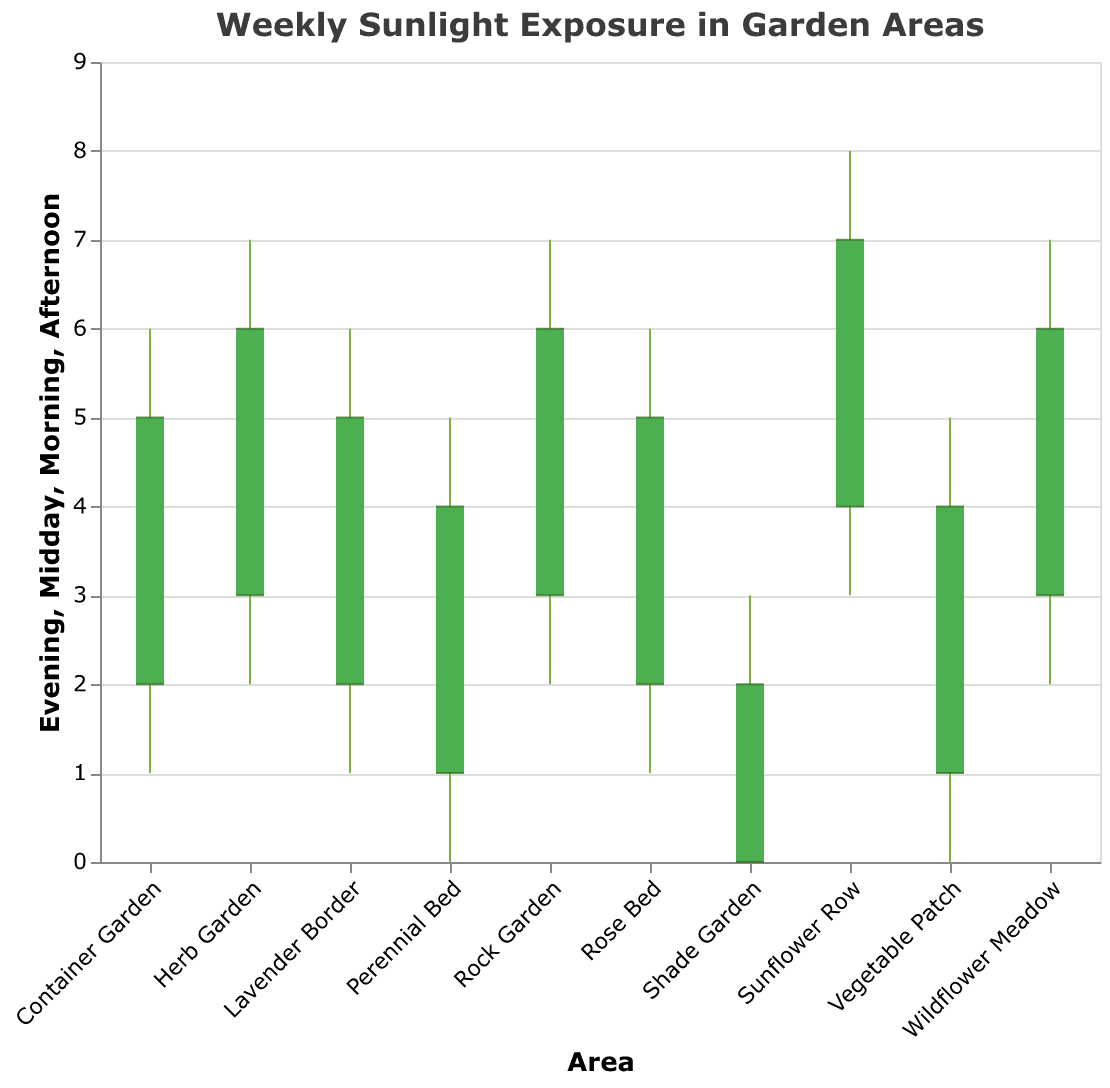What is the title of the figure? The title of the figure can be found at the top and it reads "Weekly Sunlight Exposure in Garden Areas".
Answer: Weekly Sunlight Exposure in Garden Areas Which garden area receives the most midday sunlight? From the chart, the area with the highest bar at Midday is Sunflower Row.
Answer: Sunflower Row How many hours of morning sunlight does the Vegetable Patch receive? By looking at the tick marks at the bottom of the bar for the Vegetable Patch, we can see that the morning sunlight exposure is 1 hour.
Answer: 1 hour Which garden areas receive the same amount of afternoon sunlight? By comparing the heights of the bars ending at the "Afternoon" ticks, we see that Rose Bed, Lavender Border, and Container Garden all have afternoon sunlight exposure of 5 hours.
Answer: Rose Bed, Lavender Border, and Container Garden What is the difference in evening sunlight between the Herb Garden and the Vegetable Patch? The evening sunlight exposure for Herb Garden is 2 hours and for Vegetable Patch is 0 hours. The difference is 2 - 0 = 2 hours.
Answer: 2 hours Which area experiences the least amount of sunlight in the morning? By comparing the bottommost ticks on the "Morning" part of the bars, the Shade Garden has the lowest morning sunlight exposure at 0 hours.
Answer: Shade Garden Calculate the average midday sunlight exposure for all garden areas. Sum all midday values (6 + 7 + 5 + 3 + 8 + 6 + 7 + 5 + 6 + 7) = 60. There are 10 areas, so the average is 60/10 = 6.
Answer: 6 hours Which garden areas have an equal amount of evening sunlight? Comparing the top rules (evening values), we see that Rose Bed, Lavender Border, Container Garden, and Shade Garden, and Perennial Bed all have 1 hour of evening sunlight.
Answer: Rose Bed, Lavender Border, Container Garden, and Shade Garden, and Perennial Bed What is the range of afternoon sunlight in the Herb Garden? The afternoon sunlight exposure for Herb Garden is the difference between the top of the green bar (afternoon) and the bottom (morning): 6 - 3 = 3 hours.
Answer: 3 hours Comparing Rock Garden and Wildflower Meadow, which receives more sunlight in the morning, and by how much? Rock Garden has 3 hours of morning sunlight and Wildflower Meadow also has 3 hours. The difference is 3 - 3 = 0.
Answer: Rock Garden, 0 hours 